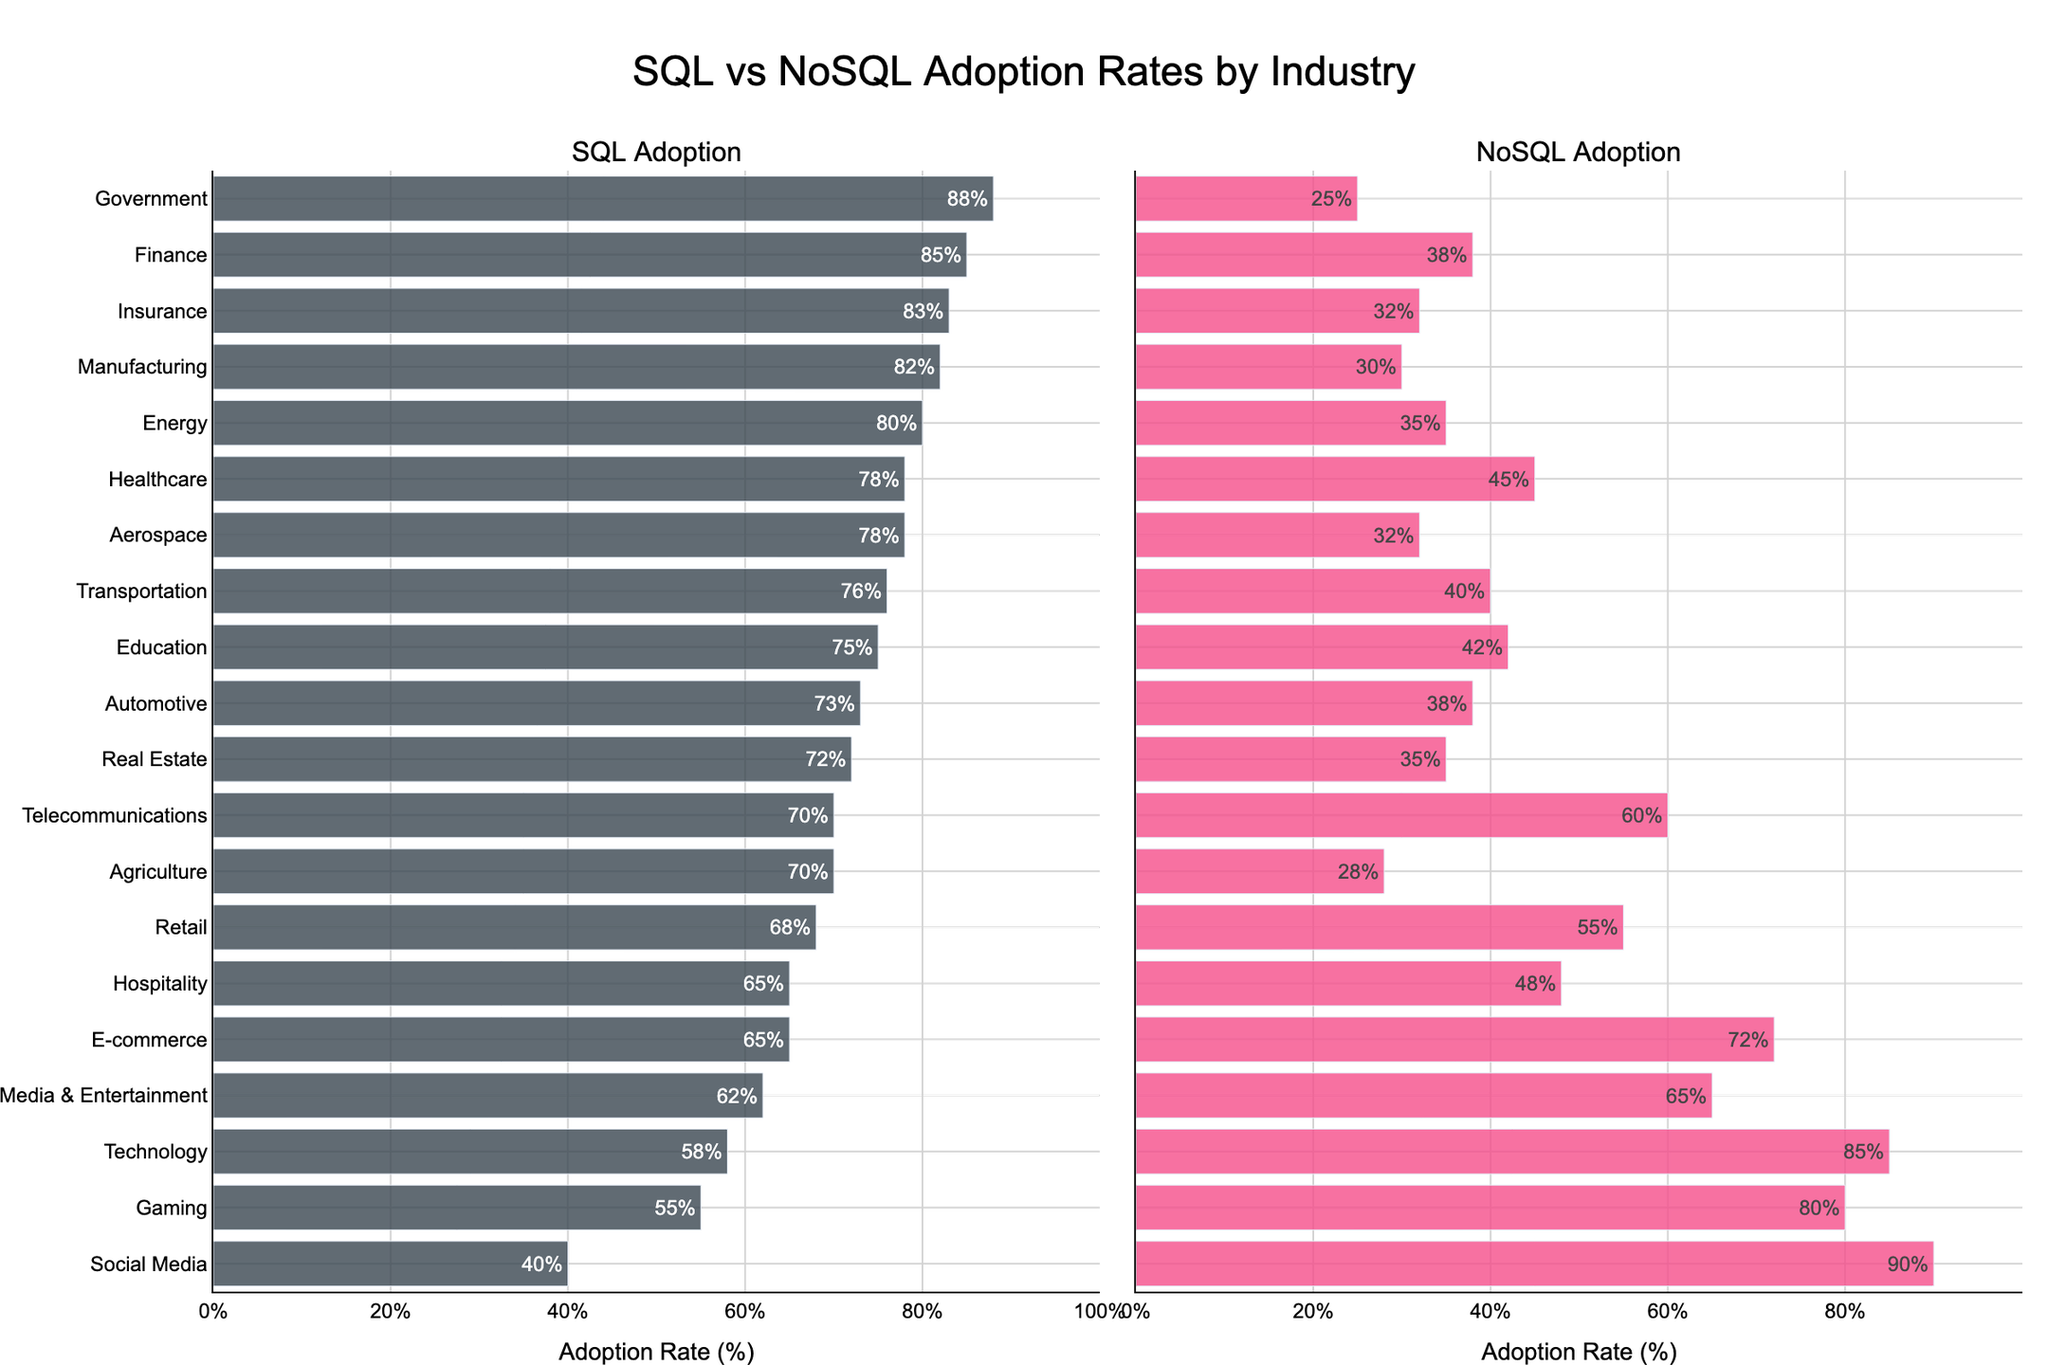Which industry has the highest SQL adoption rate? By inspecting the left subplot, we can see that the Government industry has the highest SQL adoption rate, indicated by the bar reaching 88%.
Answer: Government Which industry has the highest NoSQL adoption rate? Observing the right subplot, Social Media shows the highest NoSQL adoption rate, with a bar height corresponding to 90%.
Answer: Social Media What are the SQL and NoSQL adoption rates for the E-commerce industry? On the left subplot, the SQL adoption rate for E-commerce is 65%. On the right subplot, the NoSQL adoption rate for the same industry is 72%.
Answer: SQL: 65%, NoSQL: 72% Which industry has a higher SQL adoption rate: Finance or Technology? By examining the left subplot, Finance has a SQL adoption rate of 85%, while Technology has a rate of 58%. Thus, Finance has a higher SQL adoption rate.
Answer: Finance How many industries have a NoSQL adoption rate of 60% or higher? By counting the bars in the right subplot that reach or exceed the 60% mark, there are 7 industries: E-commerce, Social Media, Gaming, Telecommunications, Retail, Media & Entertainment, and Technology.
Answer: 7 What is the difference in SQL adoption rates between the Government and Hospitality industries? The SQL adoption rate for Government is 88% and for Hospitality is 65%. The difference is 88% - 65% = 23%.
Answer: 23% Which industry has the smallest difference between SQL and NoSQL adoption rates? By calculating the absolute differences in adoption rates for each industry, the Government industry has the smallest difference: 88% - 25% = 63%.
Answer: Government What's the average NoSQL adoption rate among the top 5 industries by SQL adoption rate? The top 5 industries by SQL adoption rate are Government, Finance, Insurance, Manufacturing, and Energy. Their NoSQL rates are 25%, 38%, 32%, 30%, and 35%. The average is (25 + 38 + 32 + 30 + 35) / 5 = 32%.
Answer: 32% In which industry is NoSQL adoption more than double the SQL adoption rate? In the right subplot, Social Media has a NoSQL adoption rate of 90%. In the left subplot, its SQL adoption rate is 40%. 90% is more than double of 40%.
Answer: Social Media Which industry has the lowest NoSQL adoption rate, and what is that rate? Checking the right subplot, Manufacturing has the lowest NoSQL adoption rate, at 30%.
Answer: Manufacturing, 30% 